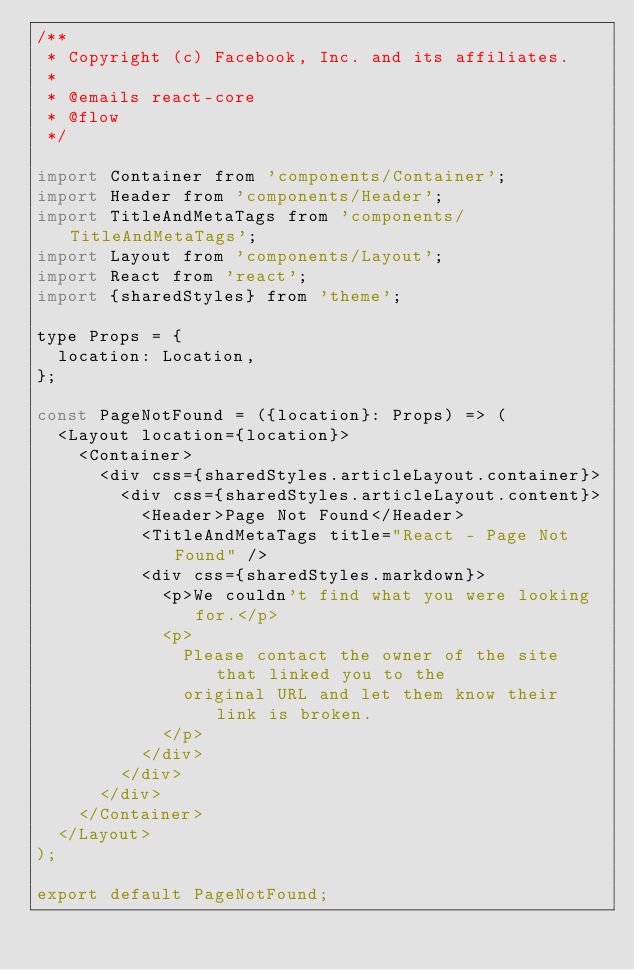Convert code to text. <code><loc_0><loc_0><loc_500><loc_500><_JavaScript_>/**
 * Copyright (c) Facebook, Inc. and its affiliates.
 *
 * @emails react-core
 * @flow
 */

import Container from 'components/Container';
import Header from 'components/Header';
import TitleAndMetaTags from 'components/TitleAndMetaTags';
import Layout from 'components/Layout';
import React from 'react';
import {sharedStyles} from 'theme';

type Props = {
  location: Location,
};

const PageNotFound = ({location}: Props) => (
  <Layout location={location}>
    <Container>
      <div css={sharedStyles.articleLayout.container}>
        <div css={sharedStyles.articleLayout.content}>
          <Header>Page Not Found</Header>
          <TitleAndMetaTags title="React - Page Not Found" />
          <div css={sharedStyles.markdown}>
            <p>We couldn't find what you were looking for.</p>
            <p>
              Please contact the owner of the site that linked you to the
              original URL and let them know their link is broken.
            </p>
          </div>
        </div>
      </div>
    </Container>
  </Layout>
);

export default PageNotFound;
</code> 